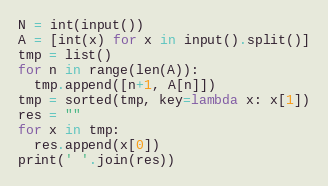Convert code to text. <code><loc_0><loc_0><loc_500><loc_500><_Python_>N = int(input())
A = [int(x) for x in input().split()]
tmp = list()
for n in range(len(A)):
  tmp.append([n+1, A[n]])
tmp = sorted(tmp, key=lambda x: x[1])
res = ""
for x in tmp:
  res.append(x[0])
print(' '.join(res))</code> 